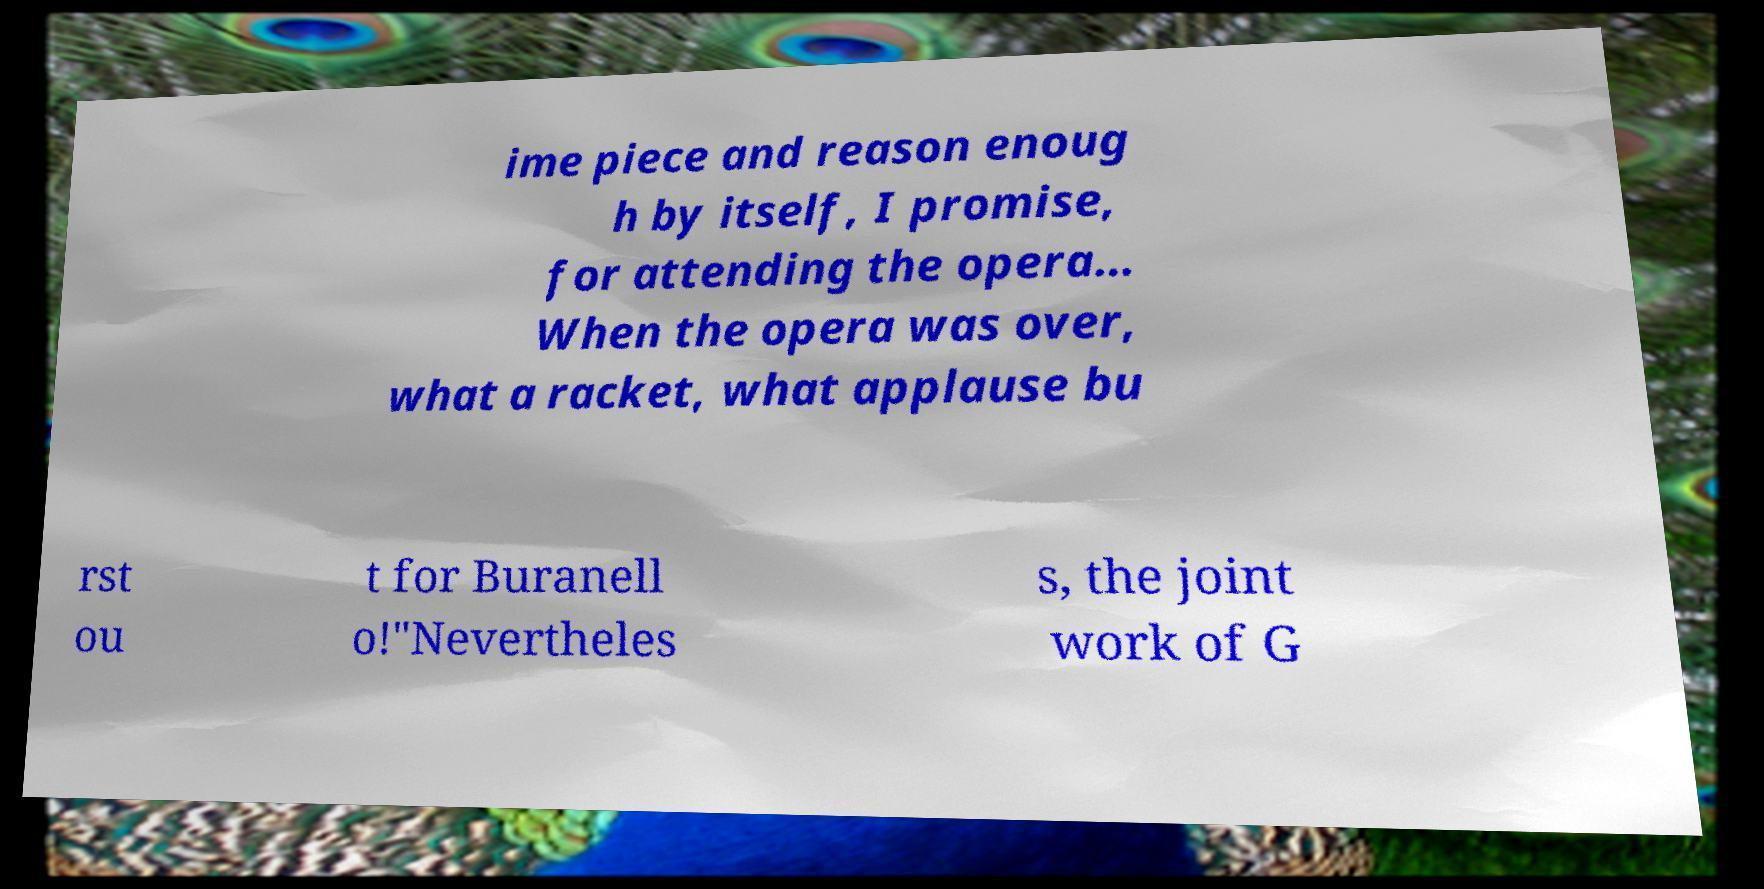Please identify and transcribe the text found in this image. ime piece and reason enoug h by itself, I promise, for attending the opera… When the opera was over, what a racket, what applause bu rst ou t for Buranell o!"Nevertheles s, the joint work of G 